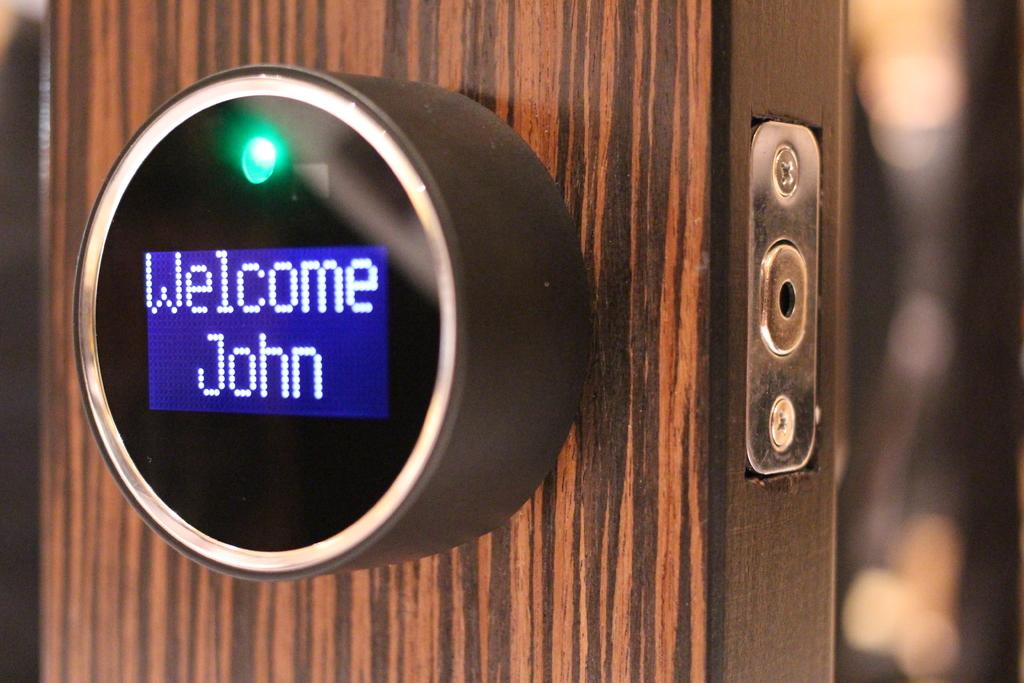<image>
Give a short and clear explanation of the subsequent image. The reader screen on the door welcome John to his room. 